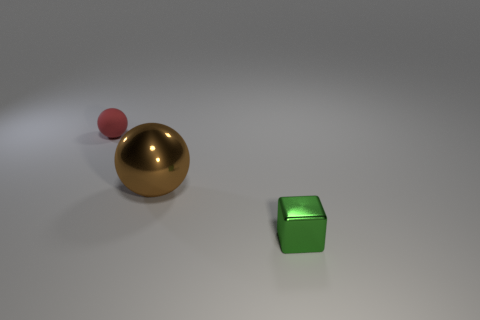Add 1 small red objects. How many objects exist? 4 Subtract 1 blocks. How many blocks are left? 0 Subtract all blocks. How many objects are left? 2 Subtract all red cubes. How many red spheres are left? 1 Subtract all brown spheres. How many spheres are left? 1 Subtract all yellow balls. Subtract all red blocks. How many balls are left? 2 Subtract all matte spheres. Subtract all gray cylinders. How many objects are left? 2 Add 2 red rubber things. How many red rubber things are left? 3 Add 1 large gray rubber objects. How many large gray rubber objects exist? 1 Subtract 0 brown cylinders. How many objects are left? 3 